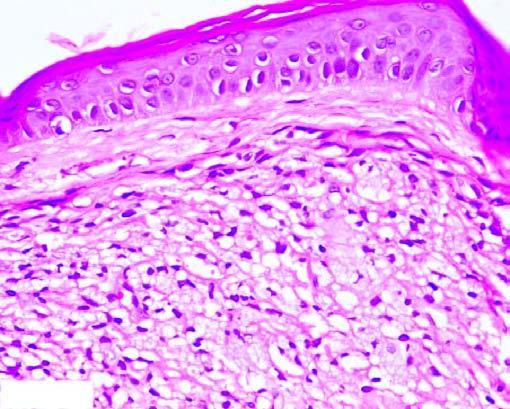s the apex collection of proliferating foam macrophages in the dermis with a clear subepidermal zone?
Answer the question using a single word or phrase. No 